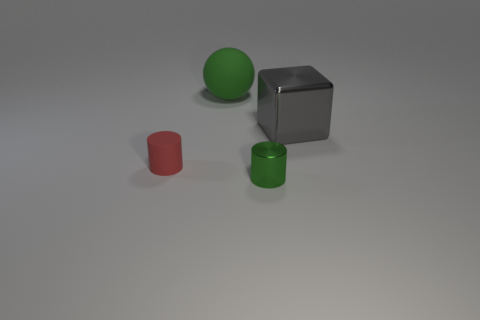Are there any tiny objects that have the same color as the big matte thing?
Provide a succinct answer. Yes. Does the tiny red thing have the same material as the cylinder that is to the right of the red cylinder?
Your answer should be compact. No. Are there any matte cylinders to the right of the large thing to the left of the gray cube?
Provide a short and direct response. No. There is a object that is both right of the green matte thing and to the left of the big cube; what color is it?
Your response must be concise. Green. What size is the gray shiny block?
Offer a very short reply. Large. How many other metal cylinders are the same size as the green cylinder?
Your answer should be compact. 0. Is the cylinder that is on the right side of the big green sphere made of the same material as the large thing that is in front of the green sphere?
Ensure brevity in your answer.  Yes. The large thing that is on the right side of the cylinder to the right of the red cylinder is made of what material?
Keep it short and to the point. Metal. There is a tiny cylinder that is left of the green ball; what is it made of?
Ensure brevity in your answer.  Rubber. How many other red objects have the same shape as the large metal object?
Keep it short and to the point. 0. 